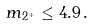<formula> <loc_0><loc_0><loc_500><loc_500>m _ { 2 ^ { + } } \leq 4 . 9 \, .</formula> 